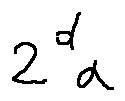<formula> <loc_0><loc_0><loc_500><loc_500>2 ^ { d } \alpha</formula> 